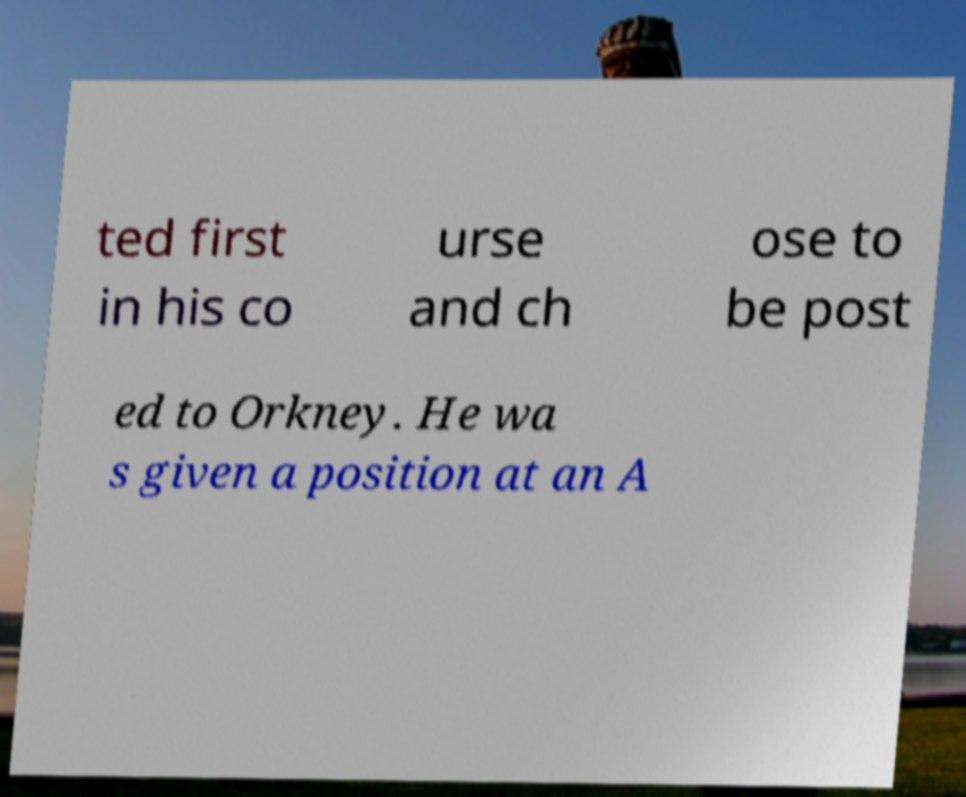Please identify and transcribe the text found in this image. ted first in his co urse and ch ose to be post ed to Orkney. He wa s given a position at an A 